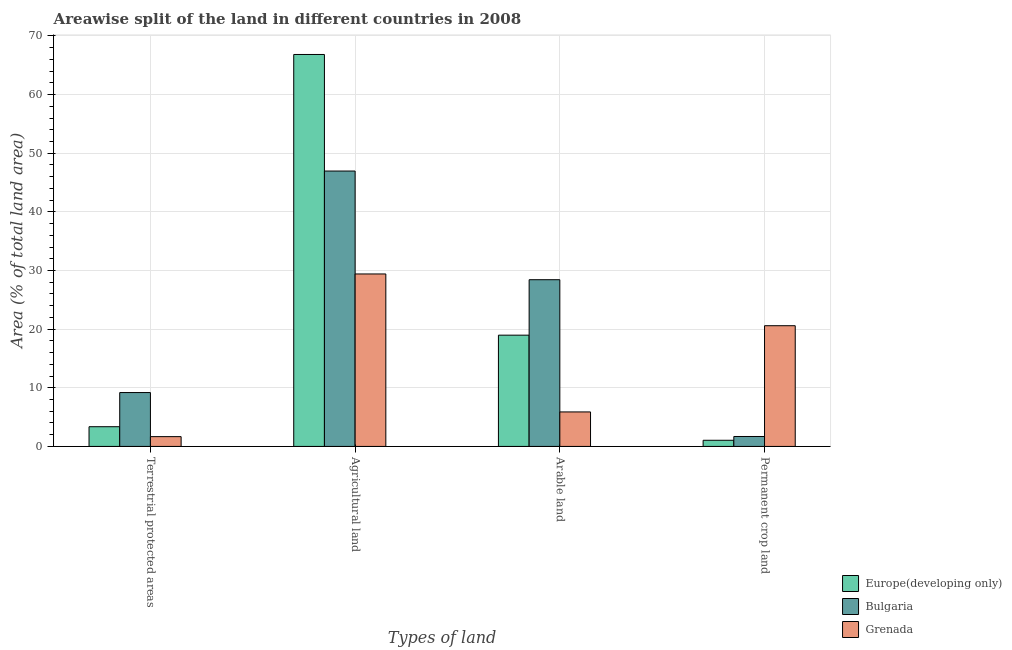How many groups of bars are there?
Your answer should be very brief. 4. Are the number of bars per tick equal to the number of legend labels?
Provide a succinct answer. Yes. Are the number of bars on each tick of the X-axis equal?
Ensure brevity in your answer.  Yes. How many bars are there on the 2nd tick from the left?
Offer a terse response. 3. What is the label of the 2nd group of bars from the left?
Your response must be concise. Agricultural land. What is the percentage of area under agricultural land in Europe(developing only)?
Your response must be concise. 66.85. Across all countries, what is the maximum percentage of land under terrestrial protection?
Your answer should be very brief. 9.19. Across all countries, what is the minimum percentage of area under agricultural land?
Offer a very short reply. 29.41. In which country was the percentage of area under permanent crop land maximum?
Ensure brevity in your answer.  Grenada. In which country was the percentage of area under arable land minimum?
Your answer should be very brief. Grenada. What is the total percentage of area under agricultural land in the graph?
Provide a short and direct response. 143.22. What is the difference between the percentage of area under permanent crop land in Grenada and that in Europe(developing only)?
Keep it short and to the point. 19.54. What is the difference between the percentage of land under terrestrial protection in Grenada and the percentage of area under permanent crop land in Europe(developing only)?
Ensure brevity in your answer.  0.62. What is the average percentage of area under agricultural land per country?
Your response must be concise. 47.74. What is the difference between the percentage of land under terrestrial protection and percentage of area under permanent crop land in Europe(developing only)?
Your response must be concise. 2.31. What is the ratio of the percentage of area under arable land in Bulgaria to that in Europe(developing only)?
Provide a short and direct response. 1.5. Is the percentage of area under permanent crop land in Grenada less than that in Europe(developing only)?
Give a very brief answer. No. Is the difference between the percentage of area under permanent crop land in Bulgaria and Europe(developing only) greater than the difference between the percentage of land under terrestrial protection in Bulgaria and Europe(developing only)?
Ensure brevity in your answer.  No. What is the difference between the highest and the second highest percentage of area under arable land?
Your answer should be very brief. 9.46. What is the difference between the highest and the lowest percentage of land under terrestrial protection?
Keep it short and to the point. 7.52. Is the sum of the percentage of area under permanent crop land in Grenada and Bulgaria greater than the maximum percentage of area under arable land across all countries?
Your response must be concise. No. Is it the case that in every country, the sum of the percentage of land under terrestrial protection and percentage of area under permanent crop land is greater than the sum of percentage of area under agricultural land and percentage of area under arable land?
Your answer should be compact. No. What does the 3rd bar from the right in Terrestrial protected areas represents?
Ensure brevity in your answer.  Europe(developing only). Are all the bars in the graph horizontal?
Provide a succinct answer. No. Are the values on the major ticks of Y-axis written in scientific E-notation?
Keep it short and to the point. No. Does the graph contain grids?
Provide a succinct answer. Yes. How are the legend labels stacked?
Your answer should be very brief. Vertical. What is the title of the graph?
Keep it short and to the point. Areawise split of the land in different countries in 2008. Does "Other small states" appear as one of the legend labels in the graph?
Provide a short and direct response. No. What is the label or title of the X-axis?
Provide a short and direct response. Types of land. What is the label or title of the Y-axis?
Offer a terse response. Area (% of total land area). What is the Area (% of total land area) in Europe(developing only) in Terrestrial protected areas?
Your answer should be very brief. 3.36. What is the Area (% of total land area) in Bulgaria in Terrestrial protected areas?
Offer a terse response. 9.19. What is the Area (% of total land area) of Grenada in Terrestrial protected areas?
Your response must be concise. 1.67. What is the Area (% of total land area) of Europe(developing only) in Agricultural land?
Offer a terse response. 66.85. What is the Area (% of total land area) of Bulgaria in Agricultural land?
Offer a terse response. 46.97. What is the Area (% of total land area) of Grenada in Agricultural land?
Give a very brief answer. 29.41. What is the Area (% of total land area) of Europe(developing only) in Arable land?
Your answer should be compact. 18.97. What is the Area (% of total land area) of Bulgaria in Arable land?
Provide a short and direct response. 28.43. What is the Area (% of total land area) of Grenada in Arable land?
Your response must be concise. 5.88. What is the Area (% of total land area) in Europe(developing only) in Permanent crop land?
Provide a succinct answer. 1.05. What is the Area (% of total land area) of Bulgaria in Permanent crop land?
Ensure brevity in your answer.  1.69. What is the Area (% of total land area) in Grenada in Permanent crop land?
Offer a terse response. 20.59. Across all Types of land, what is the maximum Area (% of total land area) of Europe(developing only)?
Provide a succinct answer. 66.85. Across all Types of land, what is the maximum Area (% of total land area) in Bulgaria?
Keep it short and to the point. 46.97. Across all Types of land, what is the maximum Area (% of total land area) of Grenada?
Offer a very short reply. 29.41. Across all Types of land, what is the minimum Area (% of total land area) in Europe(developing only)?
Provide a short and direct response. 1.05. Across all Types of land, what is the minimum Area (% of total land area) in Bulgaria?
Keep it short and to the point. 1.69. Across all Types of land, what is the minimum Area (% of total land area) in Grenada?
Give a very brief answer. 1.67. What is the total Area (% of total land area) in Europe(developing only) in the graph?
Your answer should be very brief. 90.23. What is the total Area (% of total land area) in Bulgaria in the graph?
Offer a terse response. 86.28. What is the total Area (% of total land area) in Grenada in the graph?
Your answer should be very brief. 57.55. What is the difference between the Area (% of total land area) of Europe(developing only) in Terrestrial protected areas and that in Agricultural land?
Ensure brevity in your answer.  -63.48. What is the difference between the Area (% of total land area) of Bulgaria in Terrestrial protected areas and that in Agricultural land?
Provide a short and direct response. -37.78. What is the difference between the Area (% of total land area) in Grenada in Terrestrial protected areas and that in Agricultural land?
Ensure brevity in your answer.  -27.74. What is the difference between the Area (% of total land area) in Europe(developing only) in Terrestrial protected areas and that in Arable land?
Provide a short and direct response. -15.61. What is the difference between the Area (% of total land area) of Bulgaria in Terrestrial protected areas and that in Arable land?
Provide a short and direct response. -19.24. What is the difference between the Area (% of total land area) of Grenada in Terrestrial protected areas and that in Arable land?
Offer a very short reply. -4.21. What is the difference between the Area (% of total land area) in Europe(developing only) in Terrestrial protected areas and that in Permanent crop land?
Your answer should be very brief. 2.31. What is the difference between the Area (% of total land area) of Bulgaria in Terrestrial protected areas and that in Permanent crop land?
Ensure brevity in your answer.  7.5. What is the difference between the Area (% of total land area) in Grenada in Terrestrial protected areas and that in Permanent crop land?
Provide a short and direct response. -18.92. What is the difference between the Area (% of total land area) in Europe(developing only) in Agricultural land and that in Arable land?
Ensure brevity in your answer.  47.87. What is the difference between the Area (% of total land area) in Bulgaria in Agricultural land and that in Arable land?
Your answer should be compact. 18.53. What is the difference between the Area (% of total land area) of Grenada in Agricultural land and that in Arable land?
Ensure brevity in your answer.  23.53. What is the difference between the Area (% of total land area) of Europe(developing only) in Agricultural land and that in Permanent crop land?
Offer a terse response. 65.8. What is the difference between the Area (% of total land area) in Bulgaria in Agricultural land and that in Permanent crop land?
Keep it short and to the point. 45.27. What is the difference between the Area (% of total land area) of Grenada in Agricultural land and that in Permanent crop land?
Your response must be concise. 8.82. What is the difference between the Area (% of total land area) of Europe(developing only) in Arable land and that in Permanent crop land?
Your answer should be very brief. 17.92. What is the difference between the Area (% of total land area) in Bulgaria in Arable land and that in Permanent crop land?
Your response must be concise. 26.74. What is the difference between the Area (% of total land area) in Grenada in Arable land and that in Permanent crop land?
Provide a succinct answer. -14.71. What is the difference between the Area (% of total land area) in Europe(developing only) in Terrestrial protected areas and the Area (% of total land area) in Bulgaria in Agricultural land?
Provide a short and direct response. -43.6. What is the difference between the Area (% of total land area) of Europe(developing only) in Terrestrial protected areas and the Area (% of total land area) of Grenada in Agricultural land?
Provide a short and direct response. -26.05. What is the difference between the Area (% of total land area) in Bulgaria in Terrestrial protected areas and the Area (% of total land area) in Grenada in Agricultural land?
Offer a terse response. -20.22. What is the difference between the Area (% of total land area) in Europe(developing only) in Terrestrial protected areas and the Area (% of total land area) in Bulgaria in Arable land?
Offer a very short reply. -25.07. What is the difference between the Area (% of total land area) of Europe(developing only) in Terrestrial protected areas and the Area (% of total land area) of Grenada in Arable land?
Your response must be concise. -2.52. What is the difference between the Area (% of total land area) in Bulgaria in Terrestrial protected areas and the Area (% of total land area) in Grenada in Arable land?
Your answer should be very brief. 3.31. What is the difference between the Area (% of total land area) of Europe(developing only) in Terrestrial protected areas and the Area (% of total land area) of Bulgaria in Permanent crop land?
Your answer should be very brief. 1.67. What is the difference between the Area (% of total land area) of Europe(developing only) in Terrestrial protected areas and the Area (% of total land area) of Grenada in Permanent crop land?
Give a very brief answer. -17.23. What is the difference between the Area (% of total land area) of Bulgaria in Terrestrial protected areas and the Area (% of total land area) of Grenada in Permanent crop land?
Keep it short and to the point. -11.4. What is the difference between the Area (% of total land area) in Europe(developing only) in Agricultural land and the Area (% of total land area) in Bulgaria in Arable land?
Offer a very short reply. 38.41. What is the difference between the Area (% of total land area) of Europe(developing only) in Agricultural land and the Area (% of total land area) of Grenada in Arable land?
Provide a succinct answer. 60.96. What is the difference between the Area (% of total land area) in Bulgaria in Agricultural land and the Area (% of total land area) in Grenada in Arable land?
Your response must be concise. 41.08. What is the difference between the Area (% of total land area) in Europe(developing only) in Agricultural land and the Area (% of total land area) in Bulgaria in Permanent crop land?
Provide a short and direct response. 65.15. What is the difference between the Area (% of total land area) of Europe(developing only) in Agricultural land and the Area (% of total land area) of Grenada in Permanent crop land?
Give a very brief answer. 46.26. What is the difference between the Area (% of total land area) in Bulgaria in Agricultural land and the Area (% of total land area) in Grenada in Permanent crop land?
Provide a succinct answer. 26.38. What is the difference between the Area (% of total land area) of Europe(developing only) in Arable land and the Area (% of total land area) of Bulgaria in Permanent crop land?
Your answer should be compact. 17.28. What is the difference between the Area (% of total land area) in Europe(developing only) in Arable land and the Area (% of total land area) in Grenada in Permanent crop land?
Ensure brevity in your answer.  -1.61. What is the difference between the Area (% of total land area) of Bulgaria in Arable land and the Area (% of total land area) of Grenada in Permanent crop land?
Make the answer very short. 7.84. What is the average Area (% of total land area) in Europe(developing only) per Types of land?
Provide a succinct answer. 22.56. What is the average Area (% of total land area) of Bulgaria per Types of land?
Your answer should be very brief. 21.57. What is the average Area (% of total land area) of Grenada per Types of land?
Your answer should be very brief. 14.39. What is the difference between the Area (% of total land area) of Europe(developing only) and Area (% of total land area) of Bulgaria in Terrestrial protected areas?
Keep it short and to the point. -5.83. What is the difference between the Area (% of total land area) of Europe(developing only) and Area (% of total land area) of Grenada in Terrestrial protected areas?
Make the answer very short. 1.69. What is the difference between the Area (% of total land area) of Bulgaria and Area (% of total land area) of Grenada in Terrestrial protected areas?
Your answer should be compact. 7.52. What is the difference between the Area (% of total land area) in Europe(developing only) and Area (% of total land area) in Bulgaria in Agricultural land?
Offer a terse response. 19.88. What is the difference between the Area (% of total land area) in Europe(developing only) and Area (% of total land area) in Grenada in Agricultural land?
Make the answer very short. 37.43. What is the difference between the Area (% of total land area) in Bulgaria and Area (% of total land area) in Grenada in Agricultural land?
Your response must be concise. 17.55. What is the difference between the Area (% of total land area) in Europe(developing only) and Area (% of total land area) in Bulgaria in Arable land?
Make the answer very short. -9.46. What is the difference between the Area (% of total land area) in Europe(developing only) and Area (% of total land area) in Grenada in Arable land?
Make the answer very short. 13.09. What is the difference between the Area (% of total land area) of Bulgaria and Area (% of total land area) of Grenada in Arable land?
Give a very brief answer. 22.55. What is the difference between the Area (% of total land area) in Europe(developing only) and Area (% of total land area) in Bulgaria in Permanent crop land?
Your answer should be very brief. -0.64. What is the difference between the Area (% of total land area) in Europe(developing only) and Area (% of total land area) in Grenada in Permanent crop land?
Keep it short and to the point. -19.54. What is the difference between the Area (% of total land area) of Bulgaria and Area (% of total land area) of Grenada in Permanent crop land?
Give a very brief answer. -18.89. What is the ratio of the Area (% of total land area) in Europe(developing only) in Terrestrial protected areas to that in Agricultural land?
Offer a very short reply. 0.05. What is the ratio of the Area (% of total land area) of Bulgaria in Terrestrial protected areas to that in Agricultural land?
Your answer should be very brief. 0.2. What is the ratio of the Area (% of total land area) in Grenada in Terrestrial protected areas to that in Agricultural land?
Make the answer very short. 0.06. What is the ratio of the Area (% of total land area) in Europe(developing only) in Terrestrial protected areas to that in Arable land?
Your response must be concise. 0.18. What is the ratio of the Area (% of total land area) in Bulgaria in Terrestrial protected areas to that in Arable land?
Provide a succinct answer. 0.32. What is the ratio of the Area (% of total land area) in Grenada in Terrestrial protected areas to that in Arable land?
Your response must be concise. 0.28. What is the ratio of the Area (% of total land area) in Europe(developing only) in Terrestrial protected areas to that in Permanent crop land?
Ensure brevity in your answer.  3.2. What is the ratio of the Area (% of total land area) of Bulgaria in Terrestrial protected areas to that in Permanent crop land?
Give a very brief answer. 5.42. What is the ratio of the Area (% of total land area) in Grenada in Terrestrial protected areas to that in Permanent crop land?
Keep it short and to the point. 0.08. What is the ratio of the Area (% of total land area) of Europe(developing only) in Agricultural land to that in Arable land?
Make the answer very short. 3.52. What is the ratio of the Area (% of total land area) in Bulgaria in Agricultural land to that in Arable land?
Offer a terse response. 1.65. What is the ratio of the Area (% of total land area) in Grenada in Agricultural land to that in Arable land?
Keep it short and to the point. 5. What is the ratio of the Area (% of total land area) of Europe(developing only) in Agricultural land to that in Permanent crop land?
Your answer should be compact. 63.68. What is the ratio of the Area (% of total land area) of Bulgaria in Agricultural land to that in Permanent crop land?
Provide a succinct answer. 27.72. What is the ratio of the Area (% of total land area) in Grenada in Agricultural land to that in Permanent crop land?
Keep it short and to the point. 1.43. What is the ratio of the Area (% of total land area) of Europe(developing only) in Arable land to that in Permanent crop land?
Ensure brevity in your answer.  18.08. What is the ratio of the Area (% of total land area) of Bulgaria in Arable land to that in Permanent crop land?
Ensure brevity in your answer.  16.78. What is the ratio of the Area (% of total land area) in Grenada in Arable land to that in Permanent crop land?
Your response must be concise. 0.29. What is the difference between the highest and the second highest Area (% of total land area) of Europe(developing only)?
Give a very brief answer. 47.87. What is the difference between the highest and the second highest Area (% of total land area) in Bulgaria?
Provide a succinct answer. 18.53. What is the difference between the highest and the second highest Area (% of total land area) of Grenada?
Make the answer very short. 8.82. What is the difference between the highest and the lowest Area (% of total land area) in Europe(developing only)?
Provide a short and direct response. 65.8. What is the difference between the highest and the lowest Area (% of total land area) in Bulgaria?
Provide a succinct answer. 45.27. What is the difference between the highest and the lowest Area (% of total land area) in Grenada?
Give a very brief answer. 27.74. 